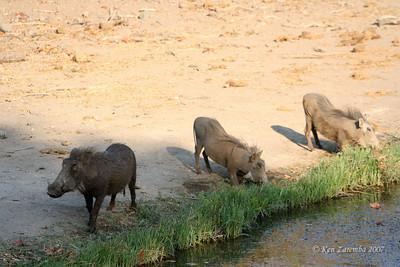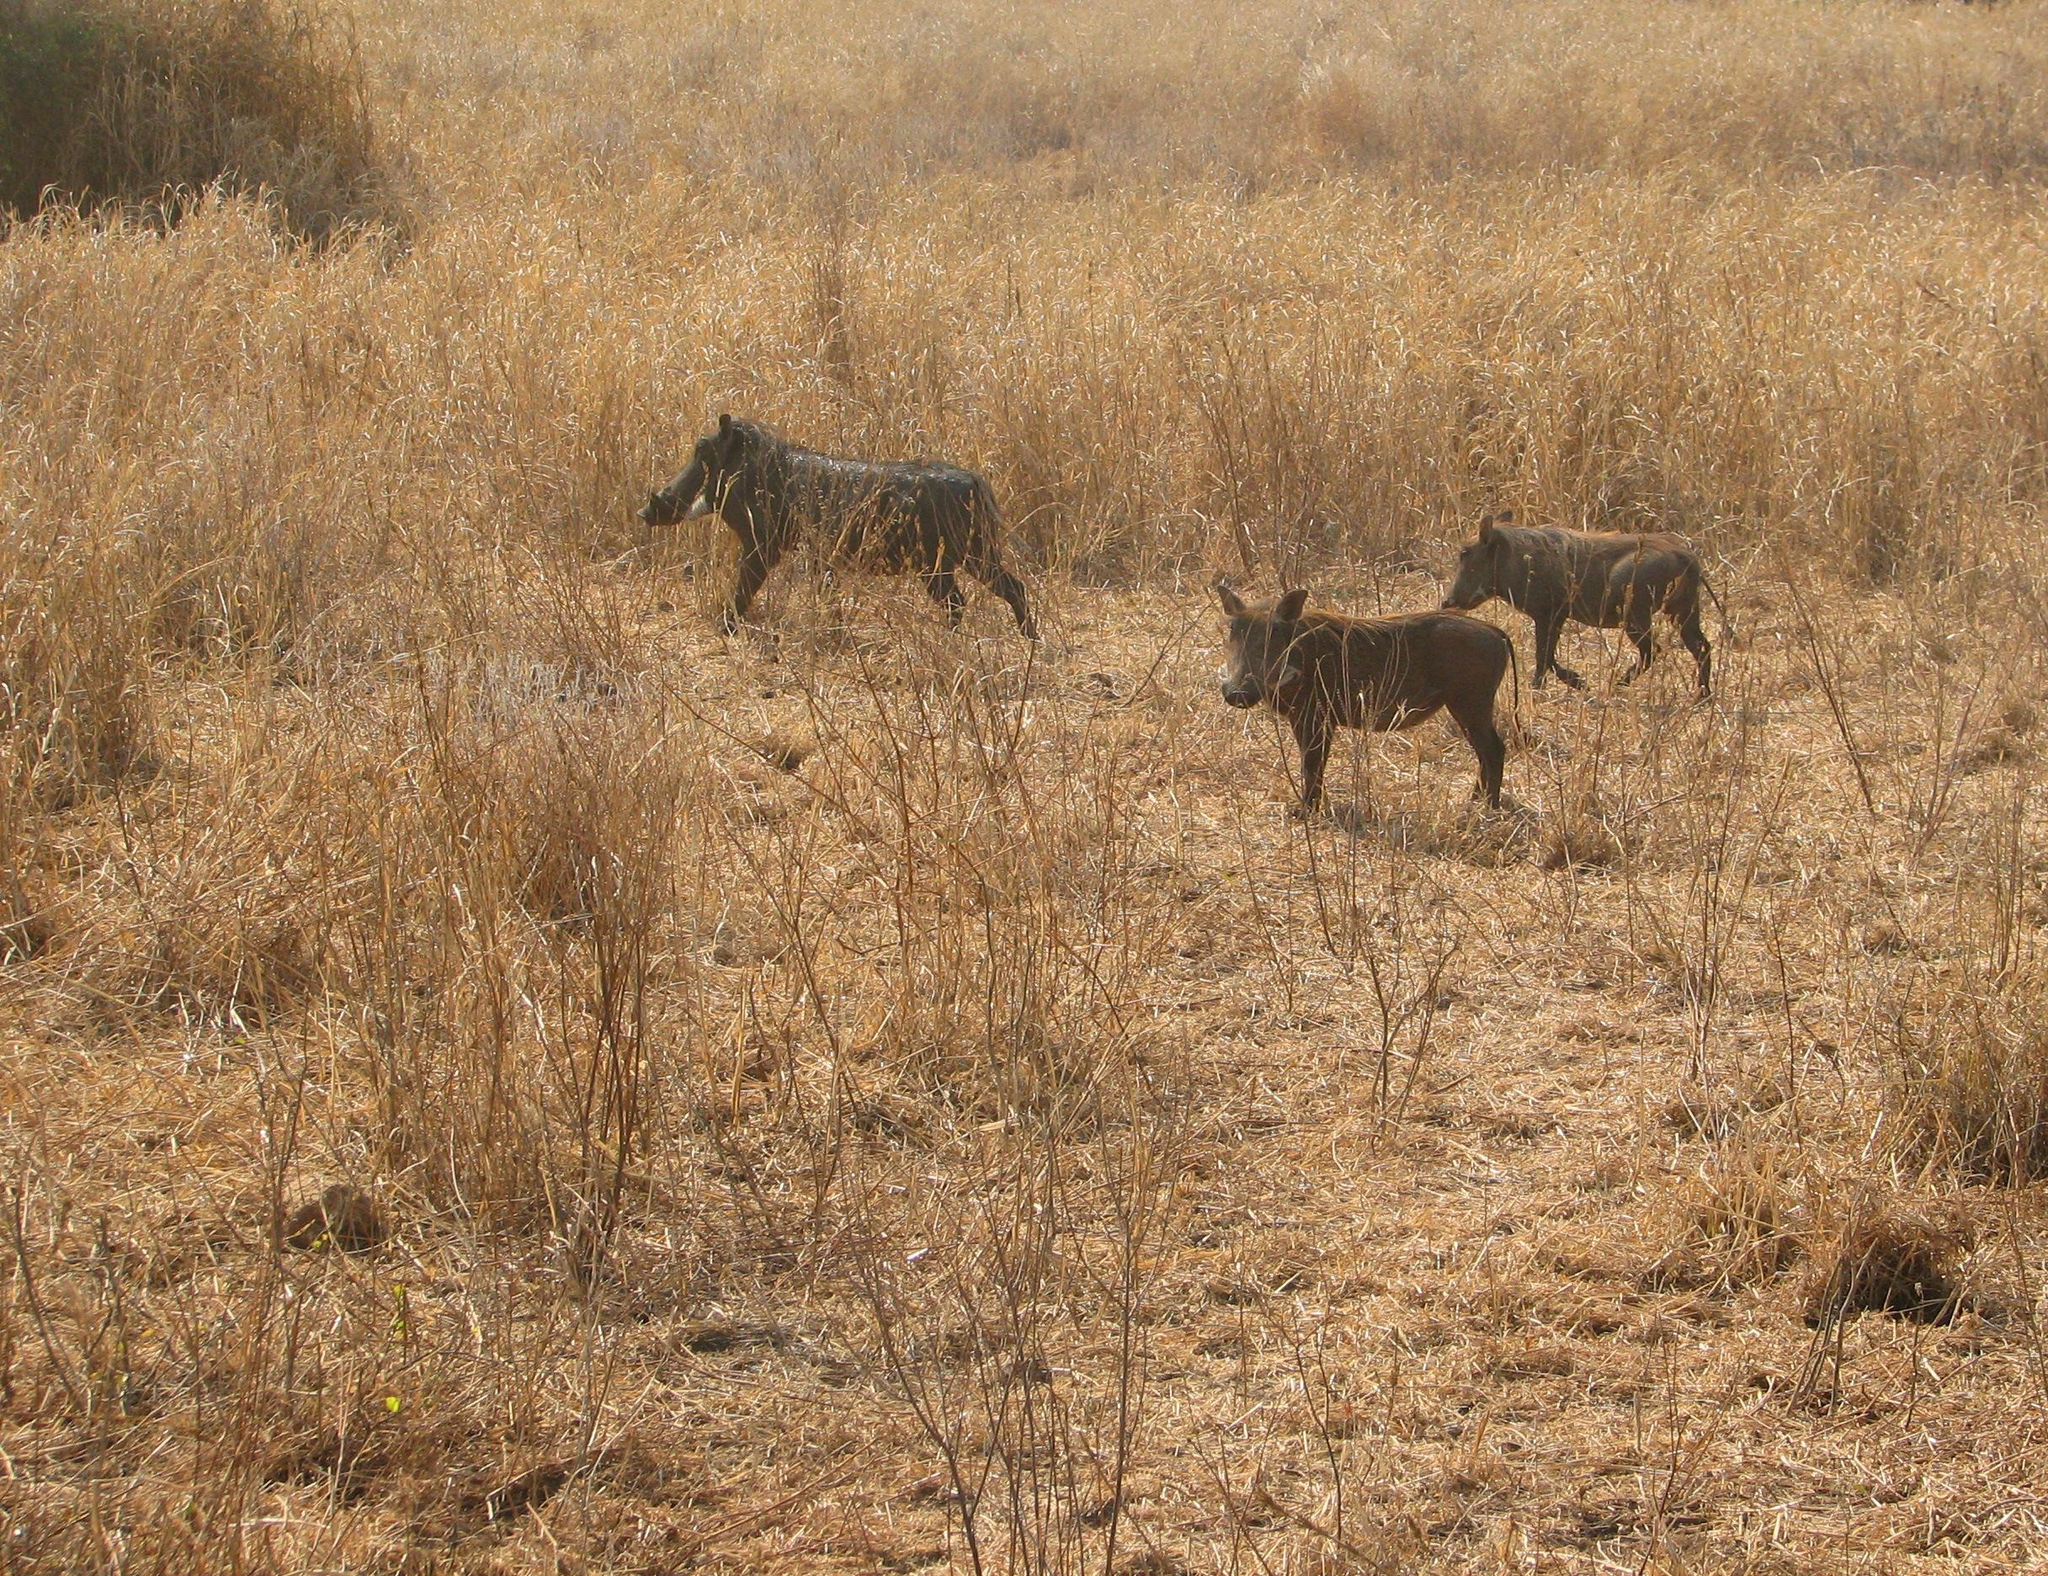The first image is the image on the left, the second image is the image on the right. For the images shown, is this caption "Multiple zebra are standing behind at least one warthog in an image." true? Answer yes or no. No. The first image is the image on the left, the second image is the image on the right. Given the left and right images, does the statement "One of the images shows a group of warthogs with a group of zebras in the background." hold true? Answer yes or no. No. 